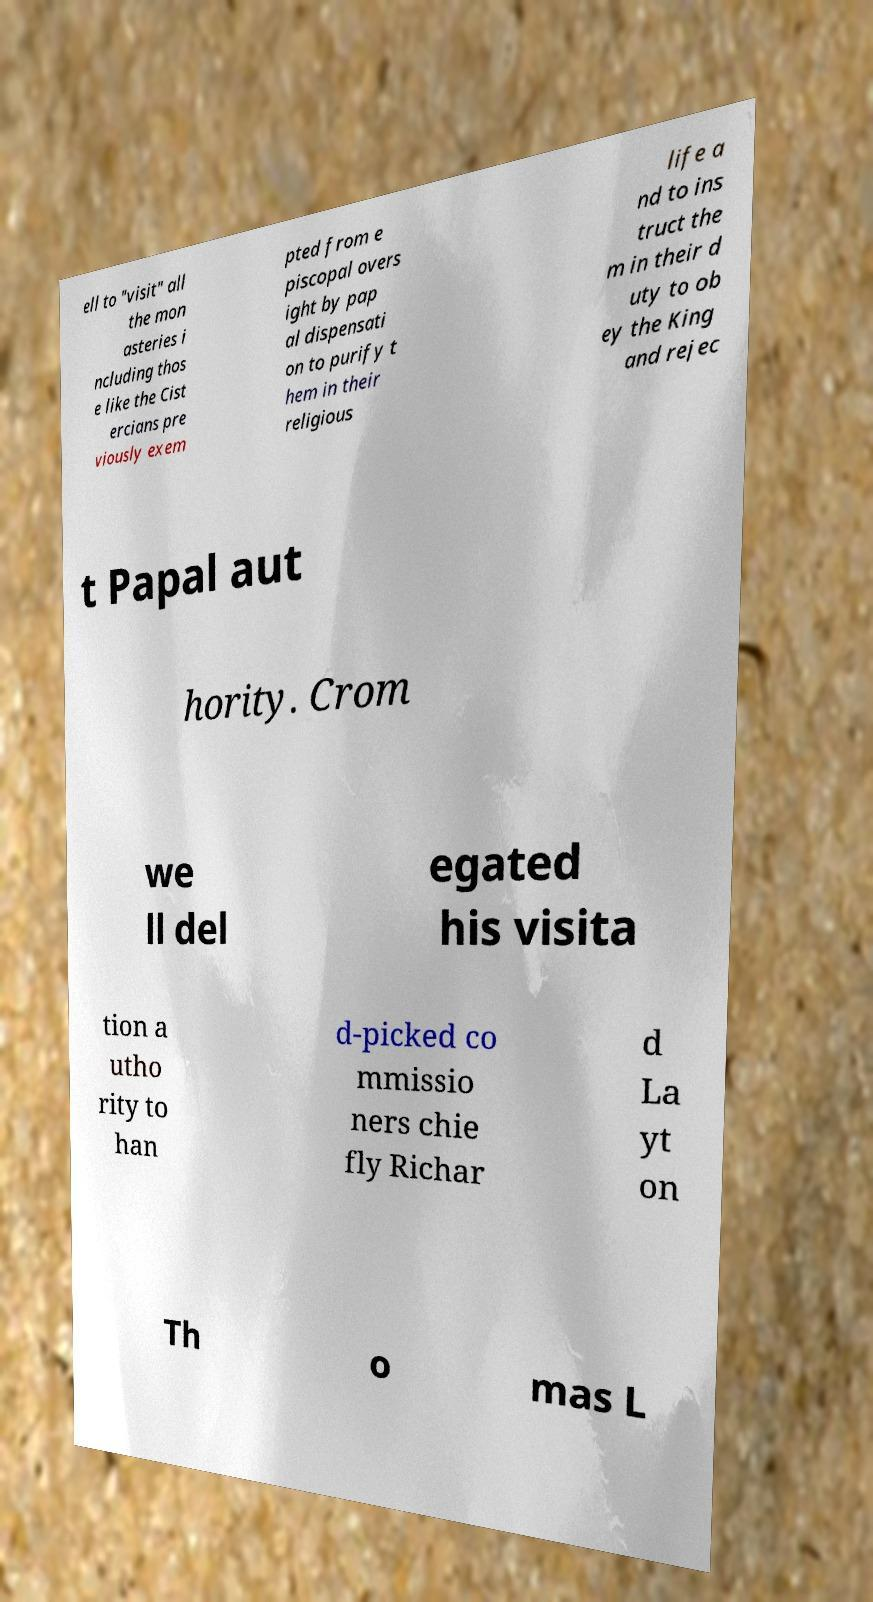Can you read and provide the text displayed in the image?This photo seems to have some interesting text. Can you extract and type it out for me? ell to "visit" all the mon asteries i ncluding thos e like the Cist ercians pre viously exem pted from e piscopal overs ight by pap al dispensati on to purify t hem in their religious life a nd to ins truct the m in their d uty to ob ey the King and rejec t Papal aut hority. Crom we ll del egated his visita tion a utho rity to han d-picked co mmissio ners chie fly Richar d La yt on Th o mas L 